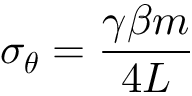Convert formula to latex. <formula><loc_0><loc_0><loc_500><loc_500>\sigma _ { \theta } = \frac { \gamma \beta m } { 4 L }</formula> 